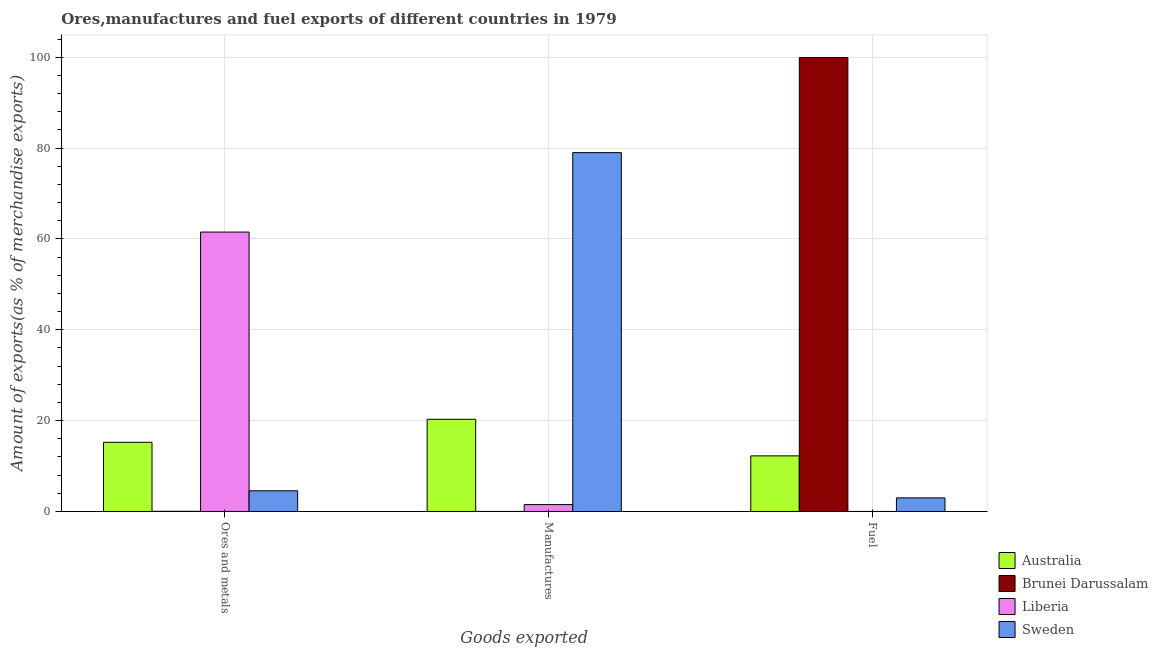How many different coloured bars are there?
Provide a succinct answer. 4. Are the number of bars on each tick of the X-axis equal?
Ensure brevity in your answer.  Yes. What is the label of the 3rd group of bars from the left?
Make the answer very short. Fuel. What is the percentage of ores and metals exports in Sweden?
Give a very brief answer. 4.55. Across all countries, what is the maximum percentage of ores and metals exports?
Keep it short and to the point. 61.51. Across all countries, what is the minimum percentage of ores and metals exports?
Your answer should be very brief. 0.03. In which country was the percentage of fuel exports maximum?
Ensure brevity in your answer.  Brunei Darussalam. In which country was the percentage of manufactures exports minimum?
Ensure brevity in your answer.  Brunei Darussalam. What is the total percentage of fuel exports in the graph?
Make the answer very short. 115.17. What is the difference between the percentage of fuel exports in Liberia and that in Brunei Darussalam?
Give a very brief answer. -99.93. What is the difference between the percentage of fuel exports in Sweden and the percentage of manufactures exports in Brunei Darussalam?
Your response must be concise. 2.99. What is the average percentage of fuel exports per country?
Your answer should be compact. 28.79. What is the difference between the percentage of ores and metals exports and percentage of manufactures exports in Brunei Darussalam?
Provide a short and direct response. 0.03. In how many countries, is the percentage of ores and metals exports greater than 16 %?
Make the answer very short. 1. What is the ratio of the percentage of manufactures exports in Sweden to that in Liberia?
Offer a very short reply. 52.07. Is the difference between the percentage of ores and metals exports in Sweden and Liberia greater than the difference between the percentage of fuel exports in Sweden and Liberia?
Keep it short and to the point. No. What is the difference between the highest and the second highest percentage of manufactures exports?
Provide a succinct answer. 58.7. What is the difference between the highest and the lowest percentage of fuel exports?
Keep it short and to the point. 99.93. In how many countries, is the percentage of ores and metals exports greater than the average percentage of ores and metals exports taken over all countries?
Your answer should be very brief. 1. What does the 2nd bar from the left in Ores and metals represents?
Give a very brief answer. Brunei Darussalam. Is it the case that in every country, the sum of the percentage of ores and metals exports and percentage of manufactures exports is greater than the percentage of fuel exports?
Your response must be concise. No. Are all the bars in the graph horizontal?
Your answer should be compact. No. Where does the legend appear in the graph?
Provide a short and direct response. Bottom right. How many legend labels are there?
Provide a short and direct response. 4. What is the title of the graph?
Offer a very short reply. Ores,manufactures and fuel exports of different countries in 1979. What is the label or title of the X-axis?
Keep it short and to the point. Goods exported. What is the label or title of the Y-axis?
Offer a terse response. Amount of exports(as % of merchandise exports). What is the Amount of exports(as % of merchandise exports) of Australia in Ores and metals?
Provide a succinct answer. 15.23. What is the Amount of exports(as % of merchandise exports) of Brunei Darussalam in Ores and metals?
Offer a very short reply. 0.03. What is the Amount of exports(as % of merchandise exports) in Liberia in Ores and metals?
Your response must be concise. 61.51. What is the Amount of exports(as % of merchandise exports) in Sweden in Ores and metals?
Your response must be concise. 4.55. What is the Amount of exports(as % of merchandise exports) in Australia in Manufactures?
Your answer should be compact. 20.3. What is the Amount of exports(as % of merchandise exports) in Brunei Darussalam in Manufactures?
Offer a terse response. 0.01. What is the Amount of exports(as % of merchandise exports) of Liberia in Manufactures?
Provide a short and direct response. 1.52. What is the Amount of exports(as % of merchandise exports) in Sweden in Manufactures?
Keep it short and to the point. 79. What is the Amount of exports(as % of merchandise exports) of Australia in Fuel?
Your answer should be compact. 12.24. What is the Amount of exports(as % of merchandise exports) of Brunei Darussalam in Fuel?
Offer a very short reply. 99.93. What is the Amount of exports(as % of merchandise exports) in Liberia in Fuel?
Offer a terse response. 0. What is the Amount of exports(as % of merchandise exports) in Sweden in Fuel?
Ensure brevity in your answer.  2.99. Across all Goods exported, what is the maximum Amount of exports(as % of merchandise exports) of Australia?
Provide a short and direct response. 20.3. Across all Goods exported, what is the maximum Amount of exports(as % of merchandise exports) of Brunei Darussalam?
Give a very brief answer. 99.93. Across all Goods exported, what is the maximum Amount of exports(as % of merchandise exports) of Liberia?
Give a very brief answer. 61.51. Across all Goods exported, what is the maximum Amount of exports(as % of merchandise exports) in Sweden?
Your answer should be very brief. 79. Across all Goods exported, what is the minimum Amount of exports(as % of merchandise exports) of Australia?
Your response must be concise. 12.24. Across all Goods exported, what is the minimum Amount of exports(as % of merchandise exports) in Brunei Darussalam?
Your answer should be compact. 0.01. Across all Goods exported, what is the minimum Amount of exports(as % of merchandise exports) of Liberia?
Offer a very short reply. 0. Across all Goods exported, what is the minimum Amount of exports(as % of merchandise exports) in Sweden?
Your answer should be compact. 2.99. What is the total Amount of exports(as % of merchandise exports) of Australia in the graph?
Offer a terse response. 47.77. What is the total Amount of exports(as % of merchandise exports) of Brunei Darussalam in the graph?
Make the answer very short. 99.97. What is the total Amount of exports(as % of merchandise exports) in Liberia in the graph?
Keep it short and to the point. 63.03. What is the total Amount of exports(as % of merchandise exports) of Sweden in the graph?
Your answer should be very brief. 86.55. What is the difference between the Amount of exports(as % of merchandise exports) of Australia in Ores and metals and that in Manufactures?
Give a very brief answer. -5.08. What is the difference between the Amount of exports(as % of merchandise exports) of Brunei Darussalam in Ores and metals and that in Manufactures?
Make the answer very short. 0.03. What is the difference between the Amount of exports(as % of merchandise exports) of Liberia in Ores and metals and that in Manufactures?
Provide a succinct answer. 60. What is the difference between the Amount of exports(as % of merchandise exports) of Sweden in Ores and metals and that in Manufactures?
Offer a terse response. -74.45. What is the difference between the Amount of exports(as % of merchandise exports) of Australia in Ores and metals and that in Fuel?
Provide a short and direct response. 2.98. What is the difference between the Amount of exports(as % of merchandise exports) of Brunei Darussalam in Ores and metals and that in Fuel?
Your answer should be compact. -99.9. What is the difference between the Amount of exports(as % of merchandise exports) of Liberia in Ores and metals and that in Fuel?
Give a very brief answer. 61.51. What is the difference between the Amount of exports(as % of merchandise exports) in Sweden in Ores and metals and that in Fuel?
Keep it short and to the point. 1.56. What is the difference between the Amount of exports(as % of merchandise exports) of Australia in Manufactures and that in Fuel?
Your response must be concise. 8.06. What is the difference between the Amount of exports(as % of merchandise exports) in Brunei Darussalam in Manufactures and that in Fuel?
Offer a terse response. -99.92. What is the difference between the Amount of exports(as % of merchandise exports) of Liberia in Manufactures and that in Fuel?
Provide a short and direct response. 1.52. What is the difference between the Amount of exports(as % of merchandise exports) of Sweden in Manufactures and that in Fuel?
Your answer should be compact. 76.01. What is the difference between the Amount of exports(as % of merchandise exports) of Australia in Ores and metals and the Amount of exports(as % of merchandise exports) of Brunei Darussalam in Manufactures?
Ensure brevity in your answer.  15.22. What is the difference between the Amount of exports(as % of merchandise exports) in Australia in Ores and metals and the Amount of exports(as % of merchandise exports) in Liberia in Manufactures?
Offer a terse response. 13.71. What is the difference between the Amount of exports(as % of merchandise exports) of Australia in Ores and metals and the Amount of exports(as % of merchandise exports) of Sweden in Manufactures?
Keep it short and to the point. -63.78. What is the difference between the Amount of exports(as % of merchandise exports) of Brunei Darussalam in Ores and metals and the Amount of exports(as % of merchandise exports) of Liberia in Manufactures?
Keep it short and to the point. -1.48. What is the difference between the Amount of exports(as % of merchandise exports) of Brunei Darussalam in Ores and metals and the Amount of exports(as % of merchandise exports) of Sweden in Manufactures?
Provide a succinct answer. -78.97. What is the difference between the Amount of exports(as % of merchandise exports) of Liberia in Ores and metals and the Amount of exports(as % of merchandise exports) of Sweden in Manufactures?
Your answer should be compact. -17.49. What is the difference between the Amount of exports(as % of merchandise exports) of Australia in Ores and metals and the Amount of exports(as % of merchandise exports) of Brunei Darussalam in Fuel?
Provide a succinct answer. -84.71. What is the difference between the Amount of exports(as % of merchandise exports) in Australia in Ores and metals and the Amount of exports(as % of merchandise exports) in Liberia in Fuel?
Make the answer very short. 15.22. What is the difference between the Amount of exports(as % of merchandise exports) in Australia in Ores and metals and the Amount of exports(as % of merchandise exports) in Sweden in Fuel?
Provide a short and direct response. 12.23. What is the difference between the Amount of exports(as % of merchandise exports) of Brunei Darussalam in Ores and metals and the Amount of exports(as % of merchandise exports) of Liberia in Fuel?
Your answer should be compact. 0.03. What is the difference between the Amount of exports(as % of merchandise exports) in Brunei Darussalam in Ores and metals and the Amount of exports(as % of merchandise exports) in Sweden in Fuel?
Your answer should be very brief. -2.96. What is the difference between the Amount of exports(as % of merchandise exports) of Liberia in Ores and metals and the Amount of exports(as % of merchandise exports) of Sweden in Fuel?
Your answer should be compact. 58.52. What is the difference between the Amount of exports(as % of merchandise exports) in Australia in Manufactures and the Amount of exports(as % of merchandise exports) in Brunei Darussalam in Fuel?
Give a very brief answer. -79.63. What is the difference between the Amount of exports(as % of merchandise exports) of Australia in Manufactures and the Amount of exports(as % of merchandise exports) of Liberia in Fuel?
Offer a very short reply. 20.3. What is the difference between the Amount of exports(as % of merchandise exports) of Australia in Manufactures and the Amount of exports(as % of merchandise exports) of Sweden in Fuel?
Your answer should be compact. 17.31. What is the difference between the Amount of exports(as % of merchandise exports) of Brunei Darussalam in Manufactures and the Amount of exports(as % of merchandise exports) of Liberia in Fuel?
Give a very brief answer. 0.01. What is the difference between the Amount of exports(as % of merchandise exports) of Brunei Darussalam in Manufactures and the Amount of exports(as % of merchandise exports) of Sweden in Fuel?
Offer a terse response. -2.99. What is the difference between the Amount of exports(as % of merchandise exports) of Liberia in Manufactures and the Amount of exports(as % of merchandise exports) of Sweden in Fuel?
Offer a terse response. -1.48. What is the average Amount of exports(as % of merchandise exports) of Australia per Goods exported?
Your answer should be very brief. 15.92. What is the average Amount of exports(as % of merchandise exports) of Brunei Darussalam per Goods exported?
Provide a succinct answer. 33.32. What is the average Amount of exports(as % of merchandise exports) of Liberia per Goods exported?
Provide a short and direct response. 21.01. What is the average Amount of exports(as % of merchandise exports) in Sweden per Goods exported?
Provide a succinct answer. 28.85. What is the difference between the Amount of exports(as % of merchandise exports) of Australia and Amount of exports(as % of merchandise exports) of Brunei Darussalam in Ores and metals?
Offer a terse response. 15.19. What is the difference between the Amount of exports(as % of merchandise exports) in Australia and Amount of exports(as % of merchandise exports) in Liberia in Ores and metals?
Make the answer very short. -46.29. What is the difference between the Amount of exports(as % of merchandise exports) of Australia and Amount of exports(as % of merchandise exports) of Sweden in Ores and metals?
Your response must be concise. 10.67. What is the difference between the Amount of exports(as % of merchandise exports) in Brunei Darussalam and Amount of exports(as % of merchandise exports) in Liberia in Ores and metals?
Provide a succinct answer. -61.48. What is the difference between the Amount of exports(as % of merchandise exports) of Brunei Darussalam and Amount of exports(as % of merchandise exports) of Sweden in Ores and metals?
Offer a very short reply. -4.52. What is the difference between the Amount of exports(as % of merchandise exports) in Liberia and Amount of exports(as % of merchandise exports) in Sweden in Ores and metals?
Offer a terse response. 56.96. What is the difference between the Amount of exports(as % of merchandise exports) in Australia and Amount of exports(as % of merchandise exports) in Brunei Darussalam in Manufactures?
Offer a very short reply. 20.29. What is the difference between the Amount of exports(as % of merchandise exports) in Australia and Amount of exports(as % of merchandise exports) in Liberia in Manufactures?
Your answer should be compact. 18.78. What is the difference between the Amount of exports(as % of merchandise exports) in Australia and Amount of exports(as % of merchandise exports) in Sweden in Manufactures?
Your answer should be very brief. -58.7. What is the difference between the Amount of exports(as % of merchandise exports) in Brunei Darussalam and Amount of exports(as % of merchandise exports) in Liberia in Manufactures?
Make the answer very short. -1.51. What is the difference between the Amount of exports(as % of merchandise exports) in Brunei Darussalam and Amount of exports(as % of merchandise exports) in Sweden in Manufactures?
Your answer should be compact. -79. What is the difference between the Amount of exports(as % of merchandise exports) of Liberia and Amount of exports(as % of merchandise exports) of Sweden in Manufactures?
Make the answer very short. -77.49. What is the difference between the Amount of exports(as % of merchandise exports) of Australia and Amount of exports(as % of merchandise exports) of Brunei Darussalam in Fuel?
Offer a terse response. -87.69. What is the difference between the Amount of exports(as % of merchandise exports) of Australia and Amount of exports(as % of merchandise exports) of Liberia in Fuel?
Offer a very short reply. 12.24. What is the difference between the Amount of exports(as % of merchandise exports) in Australia and Amount of exports(as % of merchandise exports) in Sweden in Fuel?
Give a very brief answer. 9.25. What is the difference between the Amount of exports(as % of merchandise exports) of Brunei Darussalam and Amount of exports(as % of merchandise exports) of Liberia in Fuel?
Make the answer very short. 99.93. What is the difference between the Amount of exports(as % of merchandise exports) of Brunei Darussalam and Amount of exports(as % of merchandise exports) of Sweden in Fuel?
Ensure brevity in your answer.  96.94. What is the difference between the Amount of exports(as % of merchandise exports) in Liberia and Amount of exports(as % of merchandise exports) in Sweden in Fuel?
Give a very brief answer. -2.99. What is the ratio of the Amount of exports(as % of merchandise exports) of Australia in Ores and metals to that in Manufactures?
Make the answer very short. 0.75. What is the ratio of the Amount of exports(as % of merchandise exports) of Brunei Darussalam in Ores and metals to that in Manufactures?
Offer a very short reply. 4.98. What is the ratio of the Amount of exports(as % of merchandise exports) in Liberia in Ores and metals to that in Manufactures?
Provide a succinct answer. 40.54. What is the ratio of the Amount of exports(as % of merchandise exports) of Sweden in Ores and metals to that in Manufactures?
Your answer should be compact. 0.06. What is the ratio of the Amount of exports(as % of merchandise exports) of Australia in Ores and metals to that in Fuel?
Ensure brevity in your answer.  1.24. What is the ratio of the Amount of exports(as % of merchandise exports) in Liberia in Ores and metals to that in Fuel?
Your response must be concise. 3.42e+04. What is the ratio of the Amount of exports(as % of merchandise exports) in Sweden in Ores and metals to that in Fuel?
Your answer should be very brief. 1.52. What is the ratio of the Amount of exports(as % of merchandise exports) in Australia in Manufactures to that in Fuel?
Offer a very short reply. 1.66. What is the ratio of the Amount of exports(as % of merchandise exports) of Brunei Darussalam in Manufactures to that in Fuel?
Ensure brevity in your answer.  0. What is the ratio of the Amount of exports(as % of merchandise exports) in Liberia in Manufactures to that in Fuel?
Ensure brevity in your answer.  842.58. What is the ratio of the Amount of exports(as % of merchandise exports) of Sweden in Manufactures to that in Fuel?
Make the answer very short. 26.38. What is the difference between the highest and the second highest Amount of exports(as % of merchandise exports) of Australia?
Keep it short and to the point. 5.08. What is the difference between the highest and the second highest Amount of exports(as % of merchandise exports) in Brunei Darussalam?
Your response must be concise. 99.9. What is the difference between the highest and the second highest Amount of exports(as % of merchandise exports) of Liberia?
Offer a terse response. 60. What is the difference between the highest and the second highest Amount of exports(as % of merchandise exports) of Sweden?
Make the answer very short. 74.45. What is the difference between the highest and the lowest Amount of exports(as % of merchandise exports) in Australia?
Offer a very short reply. 8.06. What is the difference between the highest and the lowest Amount of exports(as % of merchandise exports) in Brunei Darussalam?
Provide a succinct answer. 99.92. What is the difference between the highest and the lowest Amount of exports(as % of merchandise exports) of Liberia?
Provide a short and direct response. 61.51. What is the difference between the highest and the lowest Amount of exports(as % of merchandise exports) in Sweden?
Your answer should be very brief. 76.01. 